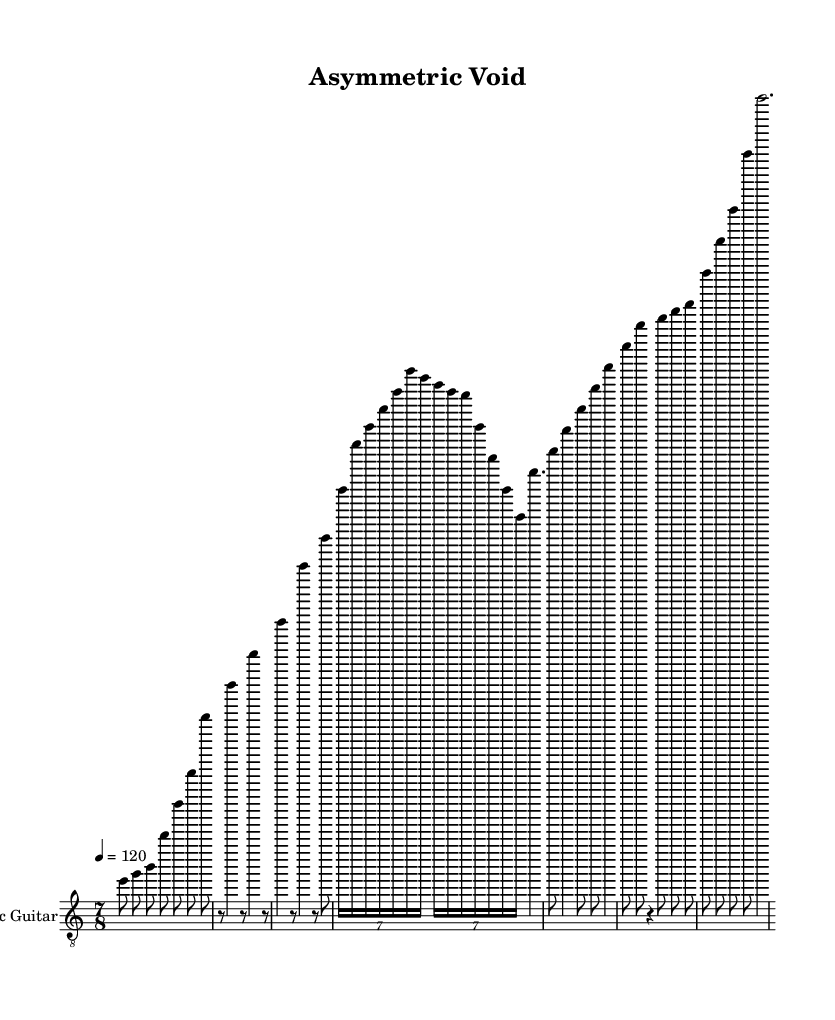What is the time signature of this music? The time signature is indicated at the beginning of the score as 7/8, meaning there are 7 eighth notes in each measure.
Answer: 7/8 What is the tempo marking in this music? The tempo marking is shown as a quarter note equals 120, meaning the piece should be played at 120 beats per minute.
Answer: 120 How many measures are in the piece? By counting the lines and measures provided in the music, there are a total of 12 measures in the score.
Answer: 12 What is the primary instrument shown in this score? The score clearly identifies the instrument as "Electric Guitar" in the staff settings at the beginning of the music.
Answer: Electric Guitar What is the length of the outro section? In the sheet music, the outro consists of a single measure where the last note is a whole note (e''2.), indicating it lasts for two beats.
Answer: 2 beats Is there a bridge section in the music? Yes, the section labeled as "Bridge" appears distinctly in the structure of the piece, as indicated between the verse and outro segments.
Answer: Yes What type of musical composition does this piece represent? This piece corresponds to the genre designation of "Avant-garde metal," characterized by its unconventional time signature, experimental sounds, and unique compositional structures.
Answer: Avant-garde metal 